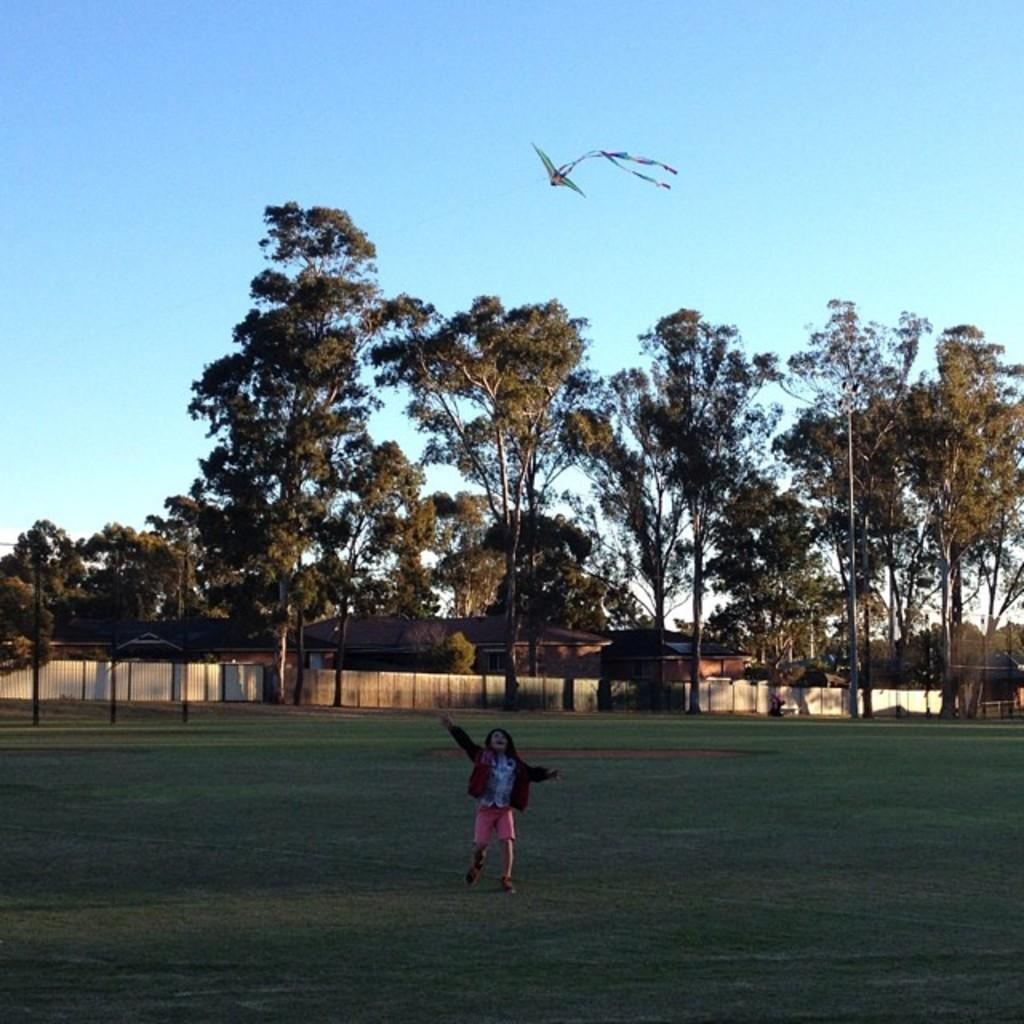What is the child in the image doing? The child is flying a kite. What can be seen in the background of the image? There are houses visible in the background. What is in front of the houses? There is a wall, trees, and poles in front of the houses. What is visible at the top of the image? The sky is visible at the top of the image. What page of the book is the child reading while flying the kite? There is no book or page visible in the image; the child is focused on flying the kite. How does the snake help the child fly the kite in the image? There is no snake present in the image; the child is flying the kite on their own. 